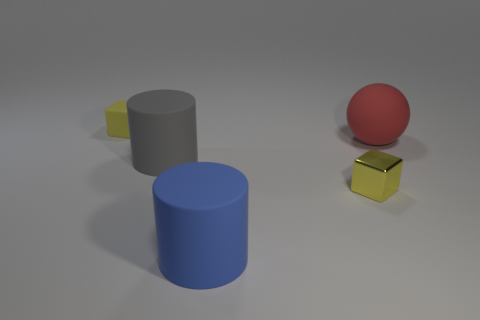Subtract all brown blocks. Subtract all blue cylinders. How many blocks are left? 2 Subtract all cyan spheres. How many cyan cubes are left? 0 Add 2 blues. How many big reds exist? 0 Subtract all green rubber objects. Subtract all tiny yellow rubber blocks. How many objects are left? 4 Add 2 small matte objects. How many small matte objects are left? 3 Add 5 green matte things. How many green matte things exist? 5 Add 1 tiny brown things. How many objects exist? 6 Subtract all gray cylinders. How many cylinders are left? 1 Subtract 0 cyan cylinders. How many objects are left? 5 Subtract all blocks. How many objects are left? 3 